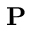<formula> <loc_0><loc_0><loc_500><loc_500>{ P }</formula> 